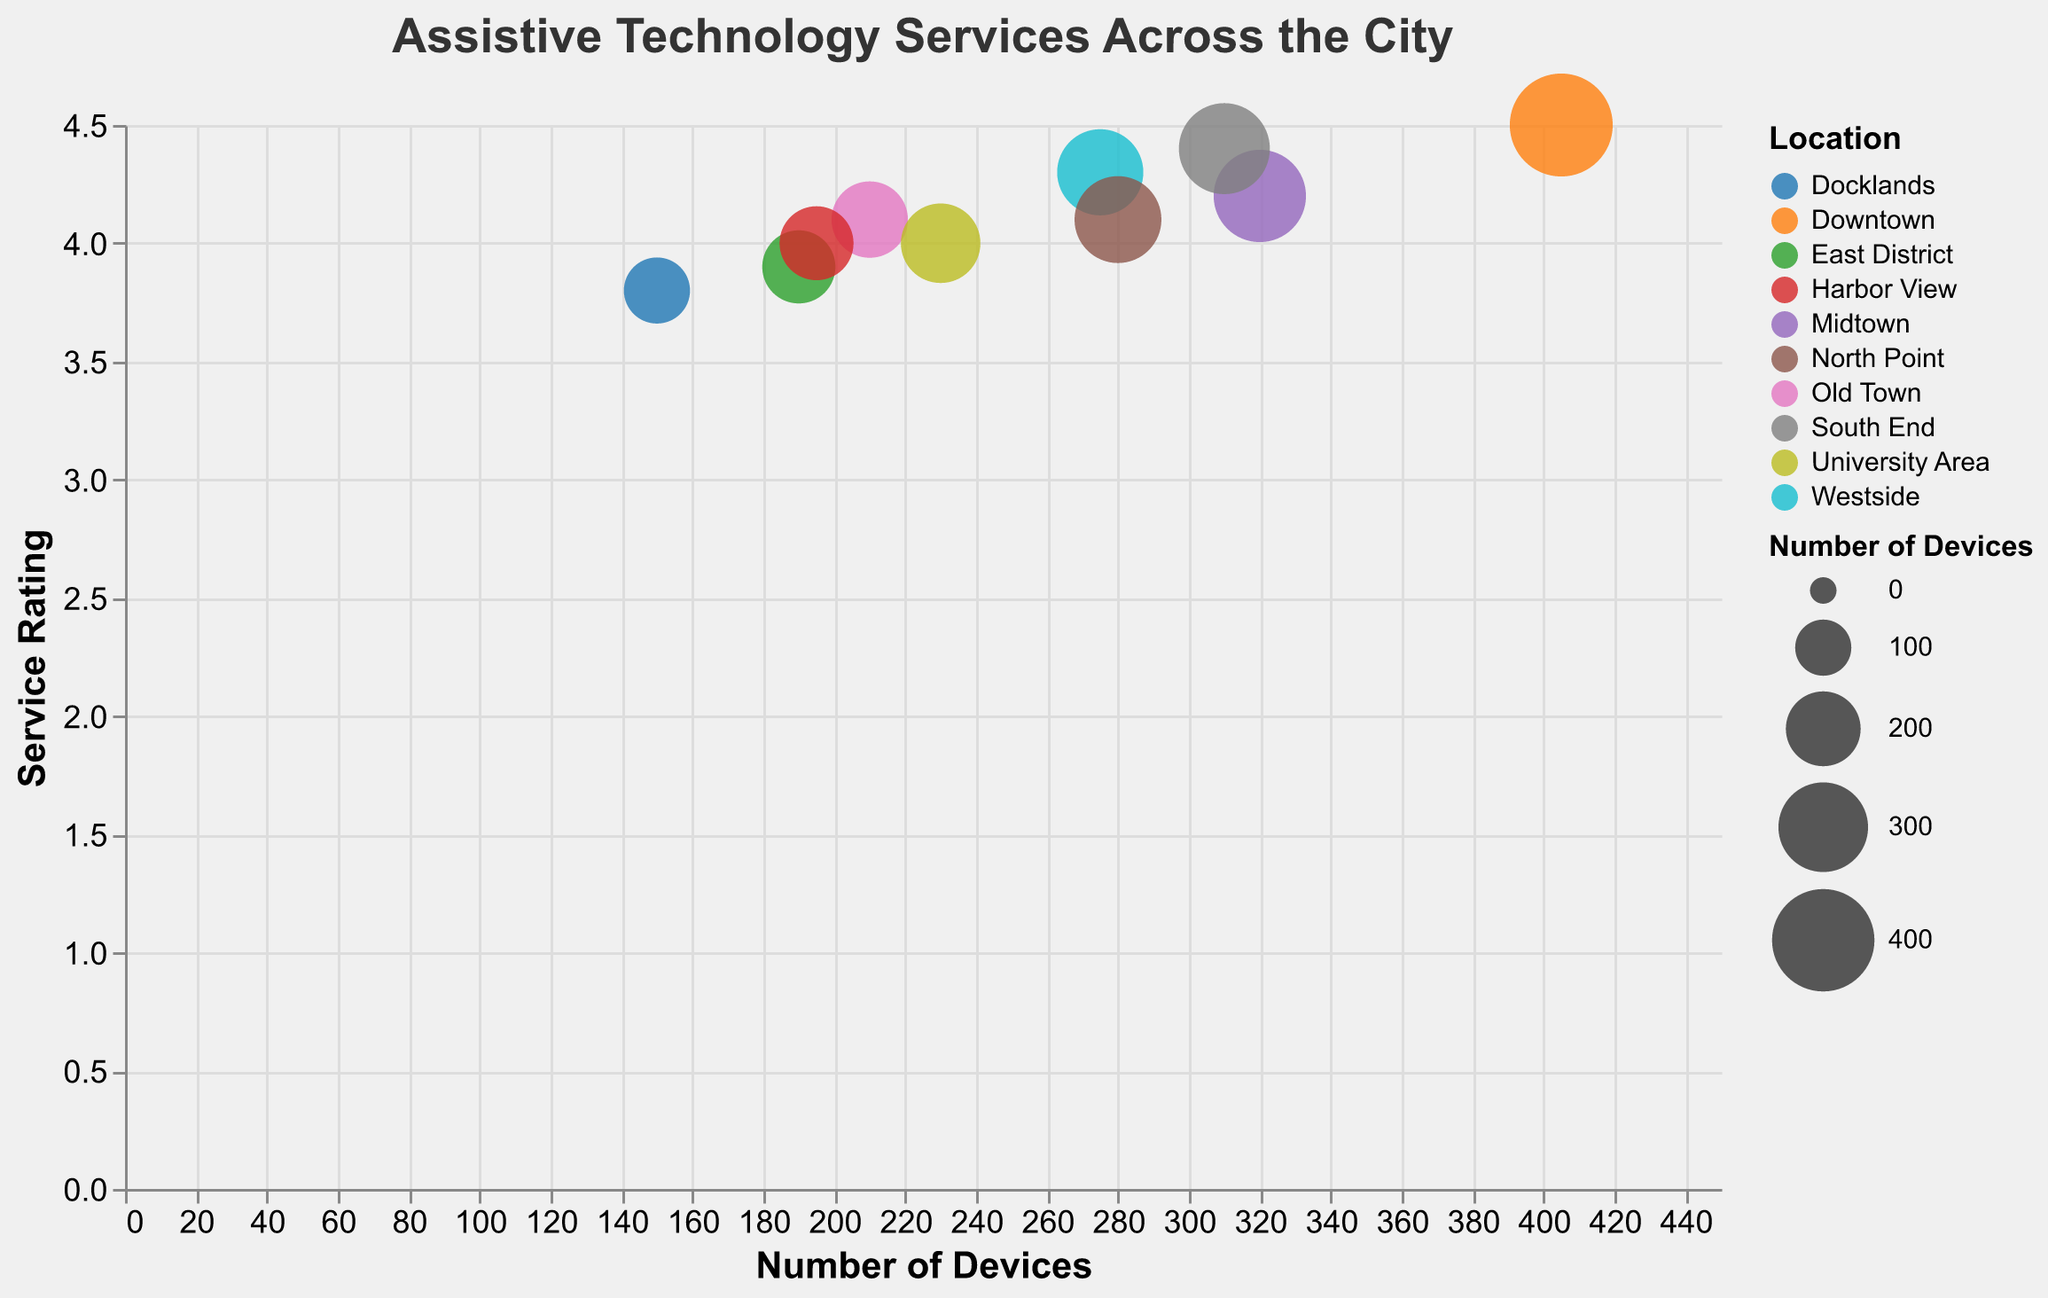What is the title of the bubble chart? The title of the chart is displayed on the top and can be read directly.
Answer: Assistive Technology Services Across the City Which service has the highest number of devices? Look for the bubble positioned furthest to the right since the x-axis represents the number of devices. The bubble farthest right is "City Vision Center".
Answer: City Vision Center What is the service rating of "Brightview Solutions"? Locate "Brightview Solutions" on the chart. The y-axis represents the service rating, so find the bubble's vertical position to determine the rating.
Answer: 4.0 Which location has the lowest service rating? Identify the bubble positioned lowest on the y-axis since that represents the service rating. The lowest is "AudioAid Services" in Docklands.
Answer: Docklands How many services have a service rating above 4.2? Count the number of bubbles positioned above the 4.2 mark on the y-axis. There are three such services.
Answer: 3 Which service has the largest bubble, and what does it represent? The size of the bubbles represents the number of devices, so identify the largest bubble. It is "City Vision Center", which indicates it has the most devices.
Answer: City Vision Center, Represents the number of devices Which service in Midtown has more devices: "Metro Accessibility Hub" or "Liberty Assistive Tech"? Compare the bubbles for both services on the x-axis (number of devices) to see which is further to the right. "Liberty Assistive Tech" in South End has more devices than "Metro Accessibility Hub" in Midtown.
Answer: Liberty Assistive Tech What is the average rating for the services? Sum all the service ratings and divide by the number of services: (4.5+4.2+4.1+4.3+3.9+4.0+4.4+4.1+3.8+4.0) / 10 = 4.13
Answer: 4.13 Which location has the highest diversity in terms of the number of devices and service ratings? Look for locations with bubbles that are spread out broadly in both the x-axis (number of devices) and y-axis (service ratings). "Midtown" and "Westside" show broad ranges in both aspects.
Answer: Midtown, Westside 